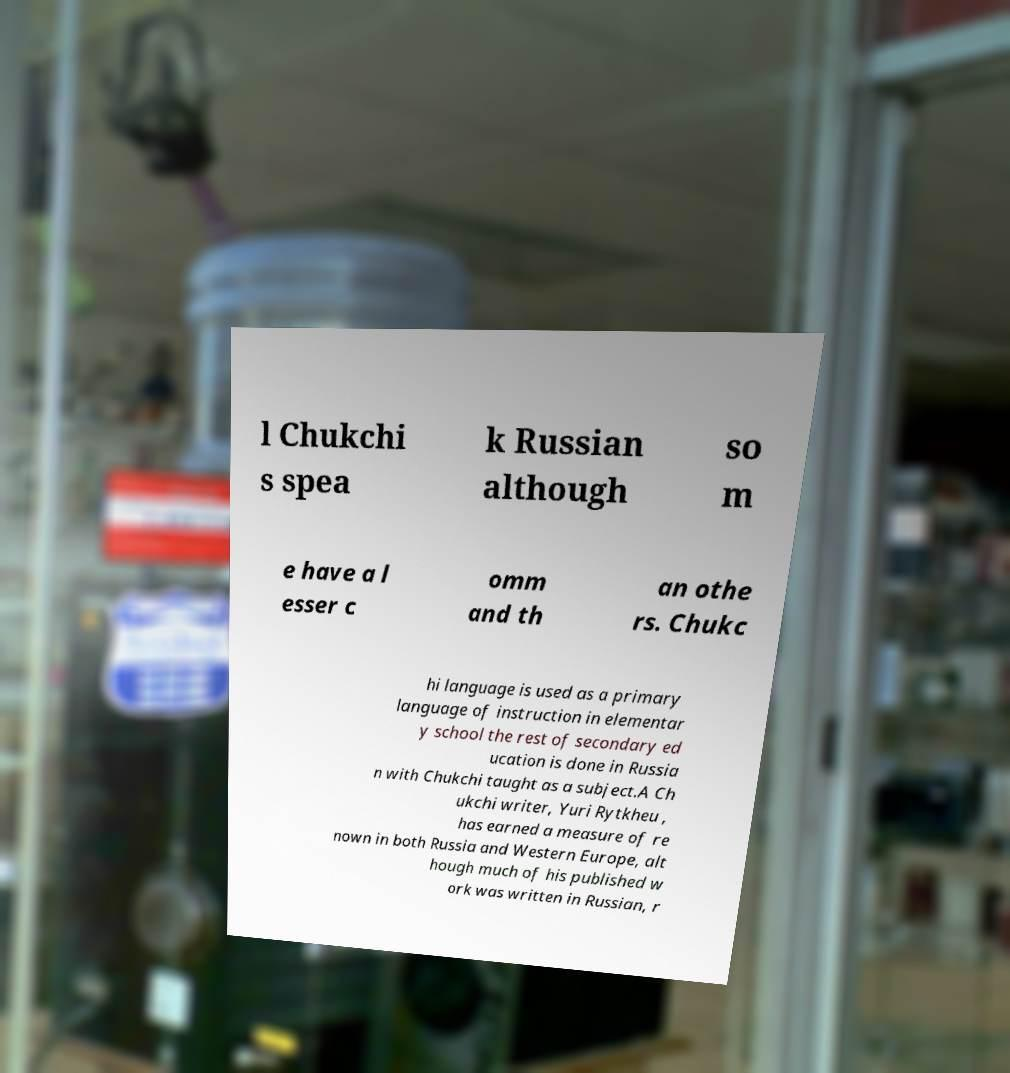What messages or text are displayed in this image? I need them in a readable, typed format. l Chukchi s spea k Russian although so m e have a l esser c omm and th an othe rs. Chukc hi language is used as a primary language of instruction in elementar y school the rest of secondary ed ucation is done in Russia n with Chukchi taught as a subject.A Ch ukchi writer, Yuri Rytkheu , has earned a measure of re nown in both Russia and Western Europe, alt hough much of his published w ork was written in Russian, r 